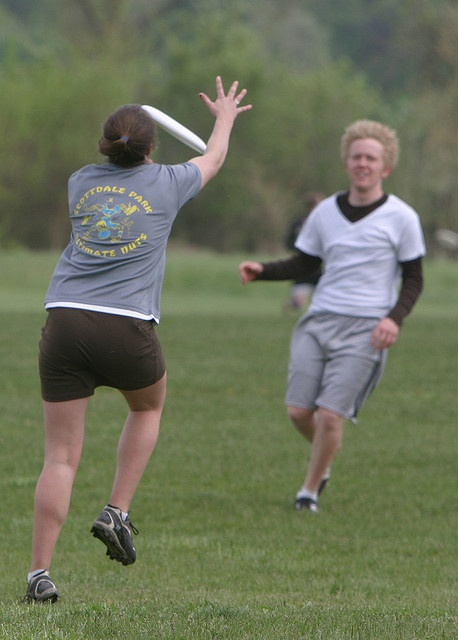Describe the objects in this image and their specific colors. I can see people in gray and black tones, people in gray, darkgray, and lavender tones, frisbee in gray, lavender, and darkgray tones, and people in gray and black tones in this image. 